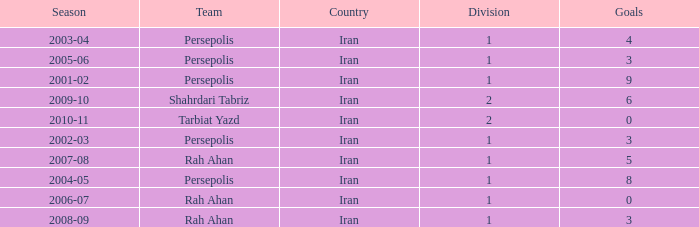What is Season, when Goals is less than 6, and when Team is "Tarbiat Yazd"? 2010-11. 